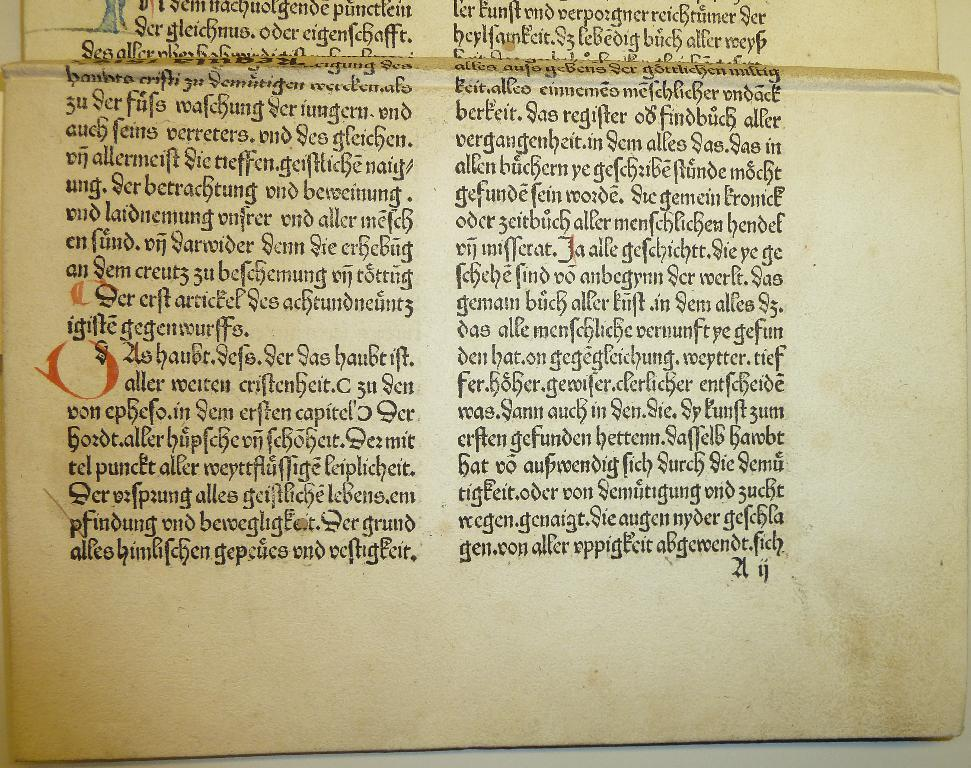<image>
Relay a brief, clear account of the picture shown. A page of a very old books with German writing in a very elaborate font. 